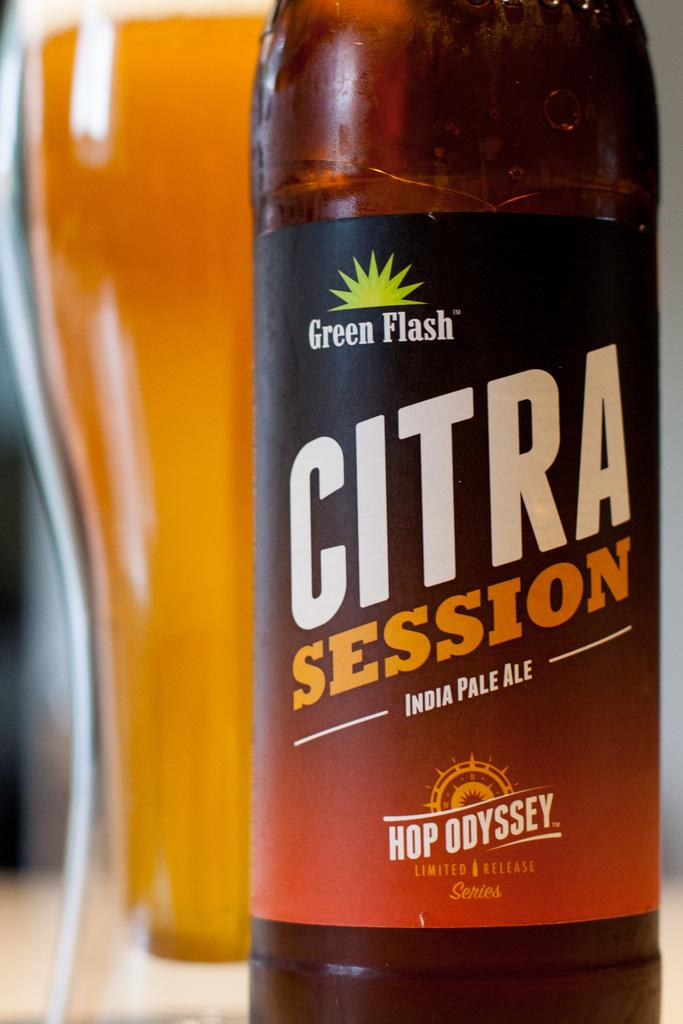<image>
Write a terse but informative summary of the picture. A brown colored India Pale Ale called Citra Session 